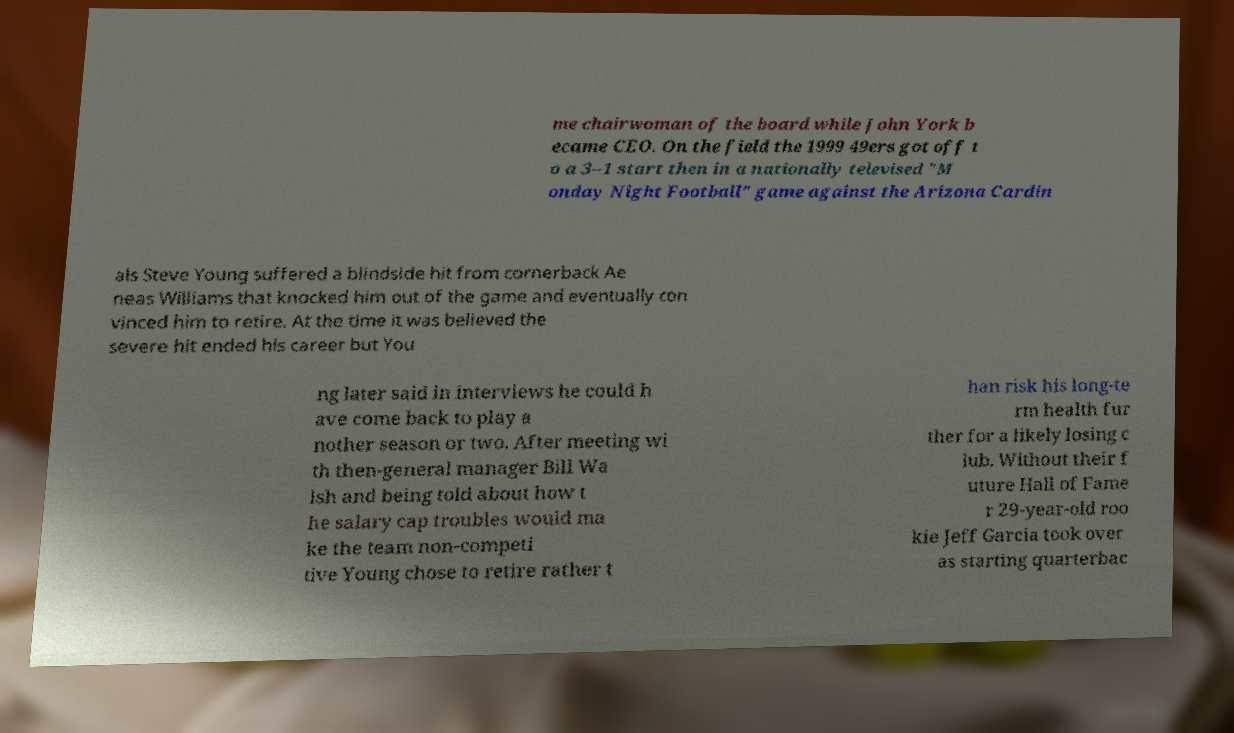Can you read and provide the text displayed in the image?This photo seems to have some interesting text. Can you extract and type it out for me? me chairwoman of the board while John York b ecame CEO. On the field the 1999 49ers got off t o a 3–1 start then in a nationally televised "M onday Night Football" game against the Arizona Cardin als Steve Young suffered a blindside hit from cornerback Ae neas Williams that knocked him out of the game and eventually con vinced him to retire. At the time it was believed the severe hit ended his career but You ng later said in interviews he could h ave come back to play a nother season or two. After meeting wi th then-general manager Bill Wa lsh and being told about how t he salary cap troubles would ma ke the team non-competi tive Young chose to retire rather t han risk his long-te rm health fur ther for a likely losing c lub. Without their f uture Hall of Fame r 29-year-old roo kie Jeff Garcia took over as starting quarterbac 